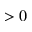Convert formula to latex. <formula><loc_0><loc_0><loc_500><loc_500>> 0</formula> 